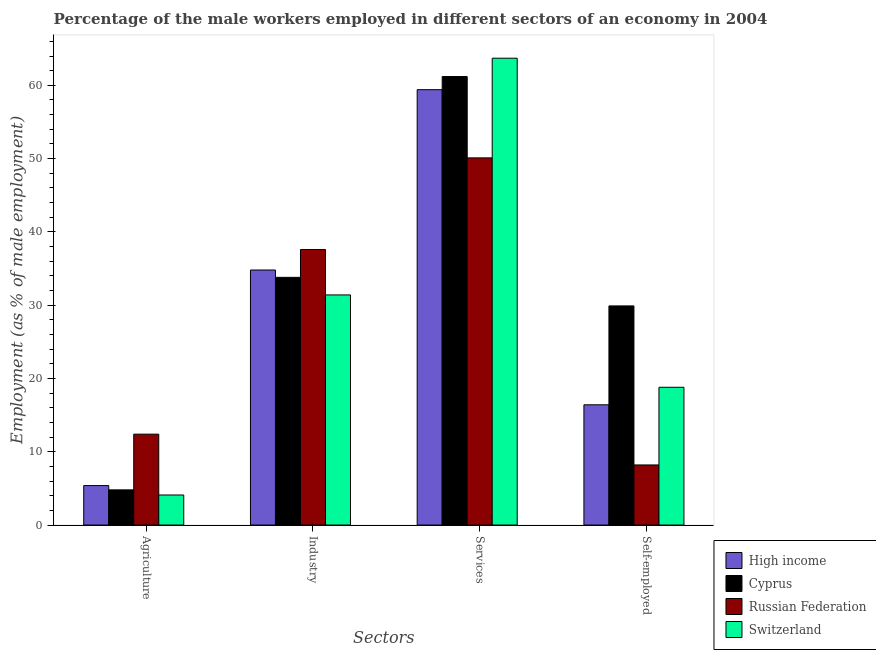How many groups of bars are there?
Offer a terse response. 4. Are the number of bars per tick equal to the number of legend labels?
Give a very brief answer. Yes. How many bars are there on the 1st tick from the left?
Provide a succinct answer. 4. How many bars are there on the 3rd tick from the right?
Give a very brief answer. 4. What is the label of the 1st group of bars from the left?
Your answer should be very brief. Agriculture. What is the percentage of male workers in industry in Switzerland?
Provide a succinct answer. 31.4. Across all countries, what is the maximum percentage of male workers in industry?
Keep it short and to the point. 37.6. Across all countries, what is the minimum percentage of male workers in services?
Your answer should be compact. 50.1. In which country was the percentage of self employed male workers maximum?
Your answer should be very brief. Cyprus. In which country was the percentage of male workers in industry minimum?
Offer a terse response. Switzerland. What is the total percentage of male workers in agriculture in the graph?
Make the answer very short. 26.69. What is the difference between the percentage of male workers in agriculture in Cyprus and that in High income?
Offer a terse response. -0.59. What is the difference between the percentage of male workers in services in Switzerland and the percentage of male workers in industry in Russian Federation?
Ensure brevity in your answer.  26.1. What is the average percentage of male workers in industry per country?
Your answer should be very brief. 34.4. What is the difference between the percentage of male workers in agriculture and percentage of male workers in industry in Russian Federation?
Offer a very short reply. -25.2. What is the ratio of the percentage of male workers in services in Switzerland to that in Russian Federation?
Provide a succinct answer. 1.27. Is the percentage of male workers in industry in Russian Federation less than that in Switzerland?
Provide a short and direct response. No. Is the difference between the percentage of self employed male workers in Cyprus and Russian Federation greater than the difference between the percentage of male workers in industry in Cyprus and Russian Federation?
Provide a short and direct response. Yes. What is the difference between the highest and the second highest percentage of male workers in agriculture?
Give a very brief answer. 7.01. What is the difference between the highest and the lowest percentage of male workers in industry?
Ensure brevity in your answer.  6.2. Is the sum of the percentage of self employed male workers in Switzerland and High income greater than the maximum percentage of male workers in services across all countries?
Offer a very short reply. No. Is it the case that in every country, the sum of the percentage of self employed male workers and percentage of male workers in agriculture is greater than the sum of percentage of male workers in services and percentage of male workers in industry?
Make the answer very short. No. What does the 2nd bar from the right in Self-employed represents?
Ensure brevity in your answer.  Russian Federation. How many bars are there?
Provide a succinct answer. 16. Are all the bars in the graph horizontal?
Your response must be concise. No. How many countries are there in the graph?
Give a very brief answer. 4. Are the values on the major ticks of Y-axis written in scientific E-notation?
Keep it short and to the point. No. What is the title of the graph?
Provide a succinct answer. Percentage of the male workers employed in different sectors of an economy in 2004. Does "Cuba" appear as one of the legend labels in the graph?
Give a very brief answer. No. What is the label or title of the X-axis?
Provide a succinct answer. Sectors. What is the label or title of the Y-axis?
Keep it short and to the point. Employment (as % of male employment). What is the Employment (as % of male employment) in High income in Agriculture?
Your answer should be very brief. 5.39. What is the Employment (as % of male employment) in Cyprus in Agriculture?
Provide a succinct answer. 4.8. What is the Employment (as % of male employment) in Russian Federation in Agriculture?
Make the answer very short. 12.4. What is the Employment (as % of male employment) of Switzerland in Agriculture?
Provide a short and direct response. 4.1. What is the Employment (as % of male employment) of High income in Industry?
Make the answer very short. 34.8. What is the Employment (as % of male employment) in Cyprus in Industry?
Your answer should be very brief. 33.8. What is the Employment (as % of male employment) of Russian Federation in Industry?
Provide a succinct answer. 37.6. What is the Employment (as % of male employment) of Switzerland in Industry?
Give a very brief answer. 31.4. What is the Employment (as % of male employment) of High income in Services?
Keep it short and to the point. 59.41. What is the Employment (as % of male employment) of Cyprus in Services?
Offer a very short reply. 61.2. What is the Employment (as % of male employment) of Russian Federation in Services?
Your answer should be compact. 50.1. What is the Employment (as % of male employment) of Switzerland in Services?
Offer a very short reply. 63.7. What is the Employment (as % of male employment) in High income in Self-employed?
Ensure brevity in your answer.  16.41. What is the Employment (as % of male employment) of Cyprus in Self-employed?
Your response must be concise. 29.9. What is the Employment (as % of male employment) of Russian Federation in Self-employed?
Your answer should be compact. 8.2. What is the Employment (as % of male employment) in Switzerland in Self-employed?
Make the answer very short. 18.8. Across all Sectors, what is the maximum Employment (as % of male employment) in High income?
Your answer should be very brief. 59.41. Across all Sectors, what is the maximum Employment (as % of male employment) of Cyprus?
Offer a terse response. 61.2. Across all Sectors, what is the maximum Employment (as % of male employment) in Russian Federation?
Your answer should be very brief. 50.1. Across all Sectors, what is the maximum Employment (as % of male employment) of Switzerland?
Keep it short and to the point. 63.7. Across all Sectors, what is the minimum Employment (as % of male employment) in High income?
Keep it short and to the point. 5.39. Across all Sectors, what is the minimum Employment (as % of male employment) of Cyprus?
Offer a very short reply. 4.8. Across all Sectors, what is the minimum Employment (as % of male employment) of Russian Federation?
Offer a very short reply. 8.2. Across all Sectors, what is the minimum Employment (as % of male employment) in Switzerland?
Give a very brief answer. 4.1. What is the total Employment (as % of male employment) of High income in the graph?
Keep it short and to the point. 116. What is the total Employment (as % of male employment) in Cyprus in the graph?
Your answer should be compact. 129.7. What is the total Employment (as % of male employment) of Russian Federation in the graph?
Provide a succinct answer. 108.3. What is the total Employment (as % of male employment) in Switzerland in the graph?
Keep it short and to the point. 118. What is the difference between the Employment (as % of male employment) of High income in Agriculture and that in Industry?
Give a very brief answer. -29.41. What is the difference between the Employment (as % of male employment) in Cyprus in Agriculture and that in Industry?
Provide a short and direct response. -29. What is the difference between the Employment (as % of male employment) in Russian Federation in Agriculture and that in Industry?
Make the answer very short. -25.2. What is the difference between the Employment (as % of male employment) of Switzerland in Agriculture and that in Industry?
Offer a terse response. -27.3. What is the difference between the Employment (as % of male employment) in High income in Agriculture and that in Services?
Make the answer very short. -54.02. What is the difference between the Employment (as % of male employment) of Cyprus in Agriculture and that in Services?
Give a very brief answer. -56.4. What is the difference between the Employment (as % of male employment) in Russian Federation in Agriculture and that in Services?
Your response must be concise. -37.7. What is the difference between the Employment (as % of male employment) in Switzerland in Agriculture and that in Services?
Your response must be concise. -59.6. What is the difference between the Employment (as % of male employment) in High income in Agriculture and that in Self-employed?
Your answer should be very brief. -11.02. What is the difference between the Employment (as % of male employment) of Cyprus in Agriculture and that in Self-employed?
Your response must be concise. -25.1. What is the difference between the Employment (as % of male employment) of Russian Federation in Agriculture and that in Self-employed?
Keep it short and to the point. 4.2. What is the difference between the Employment (as % of male employment) of Switzerland in Agriculture and that in Self-employed?
Your response must be concise. -14.7. What is the difference between the Employment (as % of male employment) in High income in Industry and that in Services?
Offer a very short reply. -24.61. What is the difference between the Employment (as % of male employment) of Cyprus in Industry and that in Services?
Provide a short and direct response. -27.4. What is the difference between the Employment (as % of male employment) in Switzerland in Industry and that in Services?
Make the answer very short. -32.3. What is the difference between the Employment (as % of male employment) of High income in Industry and that in Self-employed?
Keep it short and to the point. 18.39. What is the difference between the Employment (as % of male employment) in Cyprus in Industry and that in Self-employed?
Offer a very short reply. 3.9. What is the difference between the Employment (as % of male employment) of Russian Federation in Industry and that in Self-employed?
Your answer should be compact. 29.4. What is the difference between the Employment (as % of male employment) in High income in Services and that in Self-employed?
Give a very brief answer. 43. What is the difference between the Employment (as % of male employment) of Cyprus in Services and that in Self-employed?
Ensure brevity in your answer.  31.3. What is the difference between the Employment (as % of male employment) in Russian Federation in Services and that in Self-employed?
Provide a succinct answer. 41.9. What is the difference between the Employment (as % of male employment) in Switzerland in Services and that in Self-employed?
Provide a short and direct response. 44.9. What is the difference between the Employment (as % of male employment) in High income in Agriculture and the Employment (as % of male employment) in Cyprus in Industry?
Keep it short and to the point. -28.41. What is the difference between the Employment (as % of male employment) of High income in Agriculture and the Employment (as % of male employment) of Russian Federation in Industry?
Give a very brief answer. -32.21. What is the difference between the Employment (as % of male employment) of High income in Agriculture and the Employment (as % of male employment) of Switzerland in Industry?
Offer a terse response. -26.01. What is the difference between the Employment (as % of male employment) in Cyprus in Agriculture and the Employment (as % of male employment) in Russian Federation in Industry?
Your response must be concise. -32.8. What is the difference between the Employment (as % of male employment) in Cyprus in Agriculture and the Employment (as % of male employment) in Switzerland in Industry?
Provide a succinct answer. -26.6. What is the difference between the Employment (as % of male employment) in Russian Federation in Agriculture and the Employment (as % of male employment) in Switzerland in Industry?
Your answer should be very brief. -19. What is the difference between the Employment (as % of male employment) of High income in Agriculture and the Employment (as % of male employment) of Cyprus in Services?
Provide a succinct answer. -55.81. What is the difference between the Employment (as % of male employment) of High income in Agriculture and the Employment (as % of male employment) of Russian Federation in Services?
Your answer should be compact. -44.71. What is the difference between the Employment (as % of male employment) of High income in Agriculture and the Employment (as % of male employment) of Switzerland in Services?
Offer a terse response. -58.31. What is the difference between the Employment (as % of male employment) in Cyprus in Agriculture and the Employment (as % of male employment) in Russian Federation in Services?
Keep it short and to the point. -45.3. What is the difference between the Employment (as % of male employment) in Cyprus in Agriculture and the Employment (as % of male employment) in Switzerland in Services?
Provide a succinct answer. -58.9. What is the difference between the Employment (as % of male employment) of Russian Federation in Agriculture and the Employment (as % of male employment) of Switzerland in Services?
Make the answer very short. -51.3. What is the difference between the Employment (as % of male employment) of High income in Agriculture and the Employment (as % of male employment) of Cyprus in Self-employed?
Your answer should be very brief. -24.51. What is the difference between the Employment (as % of male employment) in High income in Agriculture and the Employment (as % of male employment) in Russian Federation in Self-employed?
Offer a very short reply. -2.81. What is the difference between the Employment (as % of male employment) of High income in Agriculture and the Employment (as % of male employment) of Switzerland in Self-employed?
Offer a terse response. -13.41. What is the difference between the Employment (as % of male employment) in Cyprus in Agriculture and the Employment (as % of male employment) in Russian Federation in Self-employed?
Provide a succinct answer. -3.4. What is the difference between the Employment (as % of male employment) of Russian Federation in Agriculture and the Employment (as % of male employment) of Switzerland in Self-employed?
Keep it short and to the point. -6.4. What is the difference between the Employment (as % of male employment) of High income in Industry and the Employment (as % of male employment) of Cyprus in Services?
Your answer should be very brief. -26.4. What is the difference between the Employment (as % of male employment) in High income in Industry and the Employment (as % of male employment) in Russian Federation in Services?
Keep it short and to the point. -15.3. What is the difference between the Employment (as % of male employment) of High income in Industry and the Employment (as % of male employment) of Switzerland in Services?
Your answer should be compact. -28.9. What is the difference between the Employment (as % of male employment) in Cyprus in Industry and the Employment (as % of male employment) in Russian Federation in Services?
Give a very brief answer. -16.3. What is the difference between the Employment (as % of male employment) of Cyprus in Industry and the Employment (as % of male employment) of Switzerland in Services?
Provide a succinct answer. -29.9. What is the difference between the Employment (as % of male employment) of Russian Federation in Industry and the Employment (as % of male employment) of Switzerland in Services?
Your answer should be very brief. -26.1. What is the difference between the Employment (as % of male employment) in High income in Industry and the Employment (as % of male employment) in Cyprus in Self-employed?
Your answer should be compact. 4.9. What is the difference between the Employment (as % of male employment) of High income in Industry and the Employment (as % of male employment) of Russian Federation in Self-employed?
Ensure brevity in your answer.  26.6. What is the difference between the Employment (as % of male employment) in High income in Industry and the Employment (as % of male employment) in Switzerland in Self-employed?
Your answer should be very brief. 16. What is the difference between the Employment (as % of male employment) of Cyprus in Industry and the Employment (as % of male employment) of Russian Federation in Self-employed?
Offer a very short reply. 25.6. What is the difference between the Employment (as % of male employment) of High income in Services and the Employment (as % of male employment) of Cyprus in Self-employed?
Offer a very short reply. 29.51. What is the difference between the Employment (as % of male employment) of High income in Services and the Employment (as % of male employment) of Russian Federation in Self-employed?
Offer a very short reply. 51.21. What is the difference between the Employment (as % of male employment) of High income in Services and the Employment (as % of male employment) of Switzerland in Self-employed?
Your answer should be compact. 40.61. What is the difference between the Employment (as % of male employment) of Cyprus in Services and the Employment (as % of male employment) of Switzerland in Self-employed?
Make the answer very short. 42.4. What is the difference between the Employment (as % of male employment) in Russian Federation in Services and the Employment (as % of male employment) in Switzerland in Self-employed?
Provide a succinct answer. 31.3. What is the average Employment (as % of male employment) of High income per Sectors?
Give a very brief answer. 29. What is the average Employment (as % of male employment) in Cyprus per Sectors?
Offer a terse response. 32.42. What is the average Employment (as % of male employment) in Russian Federation per Sectors?
Your answer should be compact. 27.07. What is the average Employment (as % of male employment) of Switzerland per Sectors?
Offer a terse response. 29.5. What is the difference between the Employment (as % of male employment) in High income and Employment (as % of male employment) in Cyprus in Agriculture?
Keep it short and to the point. 0.59. What is the difference between the Employment (as % of male employment) in High income and Employment (as % of male employment) in Russian Federation in Agriculture?
Make the answer very short. -7.01. What is the difference between the Employment (as % of male employment) in High income and Employment (as % of male employment) in Switzerland in Agriculture?
Offer a very short reply. 1.29. What is the difference between the Employment (as % of male employment) of Cyprus and Employment (as % of male employment) of Russian Federation in Agriculture?
Your response must be concise. -7.6. What is the difference between the Employment (as % of male employment) of Cyprus and Employment (as % of male employment) of Switzerland in Agriculture?
Make the answer very short. 0.7. What is the difference between the Employment (as % of male employment) in Russian Federation and Employment (as % of male employment) in Switzerland in Agriculture?
Your answer should be very brief. 8.3. What is the difference between the Employment (as % of male employment) in High income and Employment (as % of male employment) in Cyprus in Industry?
Offer a terse response. 1. What is the difference between the Employment (as % of male employment) of High income and Employment (as % of male employment) of Russian Federation in Industry?
Provide a succinct answer. -2.8. What is the difference between the Employment (as % of male employment) of High income and Employment (as % of male employment) of Switzerland in Industry?
Provide a short and direct response. 3.4. What is the difference between the Employment (as % of male employment) of High income and Employment (as % of male employment) of Cyprus in Services?
Ensure brevity in your answer.  -1.79. What is the difference between the Employment (as % of male employment) in High income and Employment (as % of male employment) in Russian Federation in Services?
Offer a terse response. 9.31. What is the difference between the Employment (as % of male employment) of High income and Employment (as % of male employment) of Switzerland in Services?
Offer a terse response. -4.29. What is the difference between the Employment (as % of male employment) of High income and Employment (as % of male employment) of Cyprus in Self-employed?
Your response must be concise. -13.49. What is the difference between the Employment (as % of male employment) of High income and Employment (as % of male employment) of Russian Federation in Self-employed?
Provide a succinct answer. 8.21. What is the difference between the Employment (as % of male employment) of High income and Employment (as % of male employment) of Switzerland in Self-employed?
Ensure brevity in your answer.  -2.39. What is the difference between the Employment (as % of male employment) in Cyprus and Employment (as % of male employment) in Russian Federation in Self-employed?
Make the answer very short. 21.7. What is the difference between the Employment (as % of male employment) in Russian Federation and Employment (as % of male employment) in Switzerland in Self-employed?
Offer a terse response. -10.6. What is the ratio of the Employment (as % of male employment) of High income in Agriculture to that in Industry?
Offer a terse response. 0.15. What is the ratio of the Employment (as % of male employment) of Cyprus in Agriculture to that in Industry?
Make the answer very short. 0.14. What is the ratio of the Employment (as % of male employment) in Russian Federation in Agriculture to that in Industry?
Your answer should be compact. 0.33. What is the ratio of the Employment (as % of male employment) in Switzerland in Agriculture to that in Industry?
Provide a succinct answer. 0.13. What is the ratio of the Employment (as % of male employment) in High income in Agriculture to that in Services?
Your answer should be compact. 0.09. What is the ratio of the Employment (as % of male employment) in Cyprus in Agriculture to that in Services?
Provide a succinct answer. 0.08. What is the ratio of the Employment (as % of male employment) of Russian Federation in Agriculture to that in Services?
Give a very brief answer. 0.25. What is the ratio of the Employment (as % of male employment) of Switzerland in Agriculture to that in Services?
Provide a short and direct response. 0.06. What is the ratio of the Employment (as % of male employment) in High income in Agriculture to that in Self-employed?
Your answer should be compact. 0.33. What is the ratio of the Employment (as % of male employment) of Cyprus in Agriculture to that in Self-employed?
Your response must be concise. 0.16. What is the ratio of the Employment (as % of male employment) of Russian Federation in Agriculture to that in Self-employed?
Offer a very short reply. 1.51. What is the ratio of the Employment (as % of male employment) of Switzerland in Agriculture to that in Self-employed?
Provide a succinct answer. 0.22. What is the ratio of the Employment (as % of male employment) in High income in Industry to that in Services?
Your response must be concise. 0.59. What is the ratio of the Employment (as % of male employment) of Cyprus in Industry to that in Services?
Provide a succinct answer. 0.55. What is the ratio of the Employment (as % of male employment) in Russian Federation in Industry to that in Services?
Your answer should be very brief. 0.75. What is the ratio of the Employment (as % of male employment) in Switzerland in Industry to that in Services?
Your answer should be compact. 0.49. What is the ratio of the Employment (as % of male employment) in High income in Industry to that in Self-employed?
Provide a short and direct response. 2.12. What is the ratio of the Employment (as % of male employment) of Cyprus in Industry to that in Self-employed?
Give a very brief answer. 1.13. What is the ratio of the Employment (as % of male employment) in Russian Federation in Industry to that in Self-employed?
Keep it short and to the point. 4.59. What is the ratio of the Employment (as % of male employment) of Switzerland in Industry to that in Self-employed?
Your answer should be very brief. 1.67. What is the ratio of the Employment (as % of male employment) of High income in Services to that in Self-employed?
Provide a short and direct response. 3.62. What is the ratio of the Employment (as % of male employment) of Cyprus in Services to that in Self-employed?
Your answer should be very brief. 2.05. What is the ratio of the Employment (as % of male employment) of Russian Federation in Services to that in Self-employed?
Offer a terse response. 6.11. What is the ratio of the Employment (as % of male employment) in Switzerland in Services to that in Self-employed?
Provide a short and direct response. 3.39. What is the difference between the highest and the second highest Employment (as % of male employment) of High income?
Offer a very short reply. 24.61. What is the difference between the highest and the second highest Employment (as % of male employment) in Cyprus?
Offer a very short reply. 27.4. What is the difference between the highest and the second highest Employment (as % of male employment) in Russian Federation?
Make the answer very short. 12.5. What is the difference between the highest and the second highest Employment (as % of male employment) of Switzerland?
Your answer should be very brief. 32.3. What is the difference between the highest and the lowest Employment (as % of male employment) in High income?
Ensure brevity in your answer.  54.02. What is the difference between the highest and the lowest Employment (as % of male employment) of Cyprus?
Offer a very short reply. 56.4. What is the difference between the highest and the lowest Employment (as % of male employment) of Russian Federation?
Ensure brevity in your answer.  41.9. What is the difference between the highest and the lowest Employment (as % of male employment) in Switzerland?
Your answer should be compact. 59.6. 